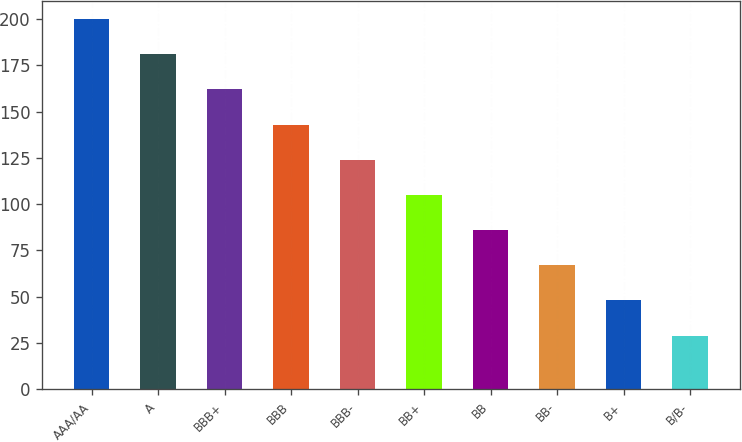<chart> <loc_0><loc_0><loc_500><loc_500><bar_chart><fcel>AAA/AA<fcel>A<fcel>BBB+<fcel>BBB<fcel>BBB-<fcel>BB+<fcel>BB<fcel>BB-<fcel>B+<fcel>B/B-<nl><fcel>200<fcel>181<fcel>162<fcel>143<fcel>124<fcel>105<fcel>86<fcel>67<fcel>48<fcel>29<nl></chart> 